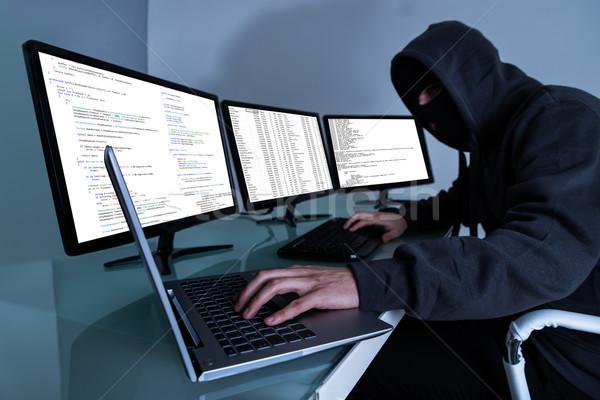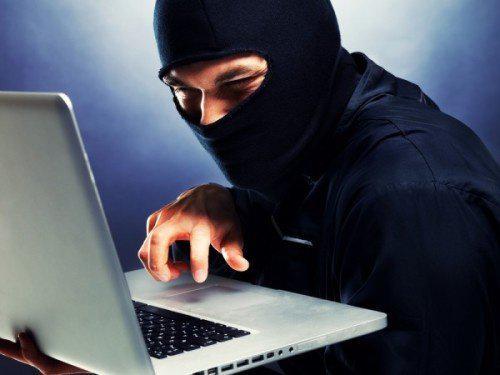The first image is the image on the left, the second image is the image on the right. Evaluate the accuracy of this statement regarding the images: "a masked man is viewing 3 monitors on a desk". Is it true? Answer yes or no. Yes. The first image is the image on the left, the second image is the image on the right. Examine the images to the left and right. Is the description "In the left image, there's a man in a mask and hoodie typing on a keyboard with three monitors." accurate? Answer yes or no. Yes. 